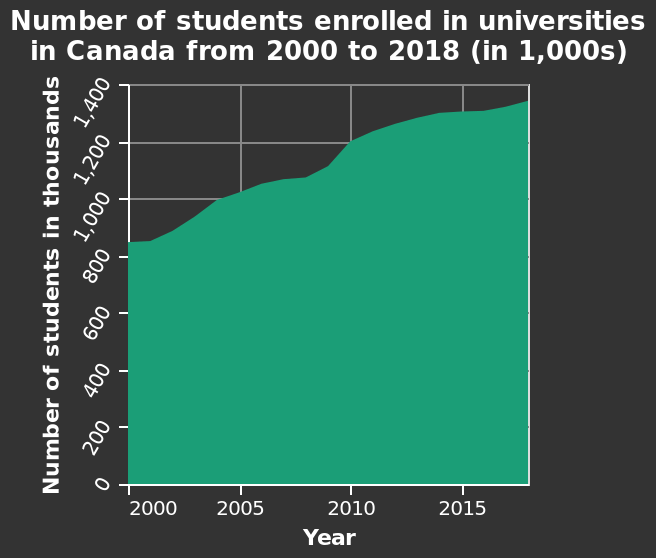<image>
What is the title of the area plot? The area plot represents the "Number of students enrolled in universities in Canada from 2000 to 2018 (in 1,000s)". What can be concluded about the growth of university enrollment in Canada based on the given information? Based on the given information, it can be concluded that there was a consistent increase in the number of students enrolled in university in Canada from 2000 to 2018, with the highest number of students attending in 2018. 